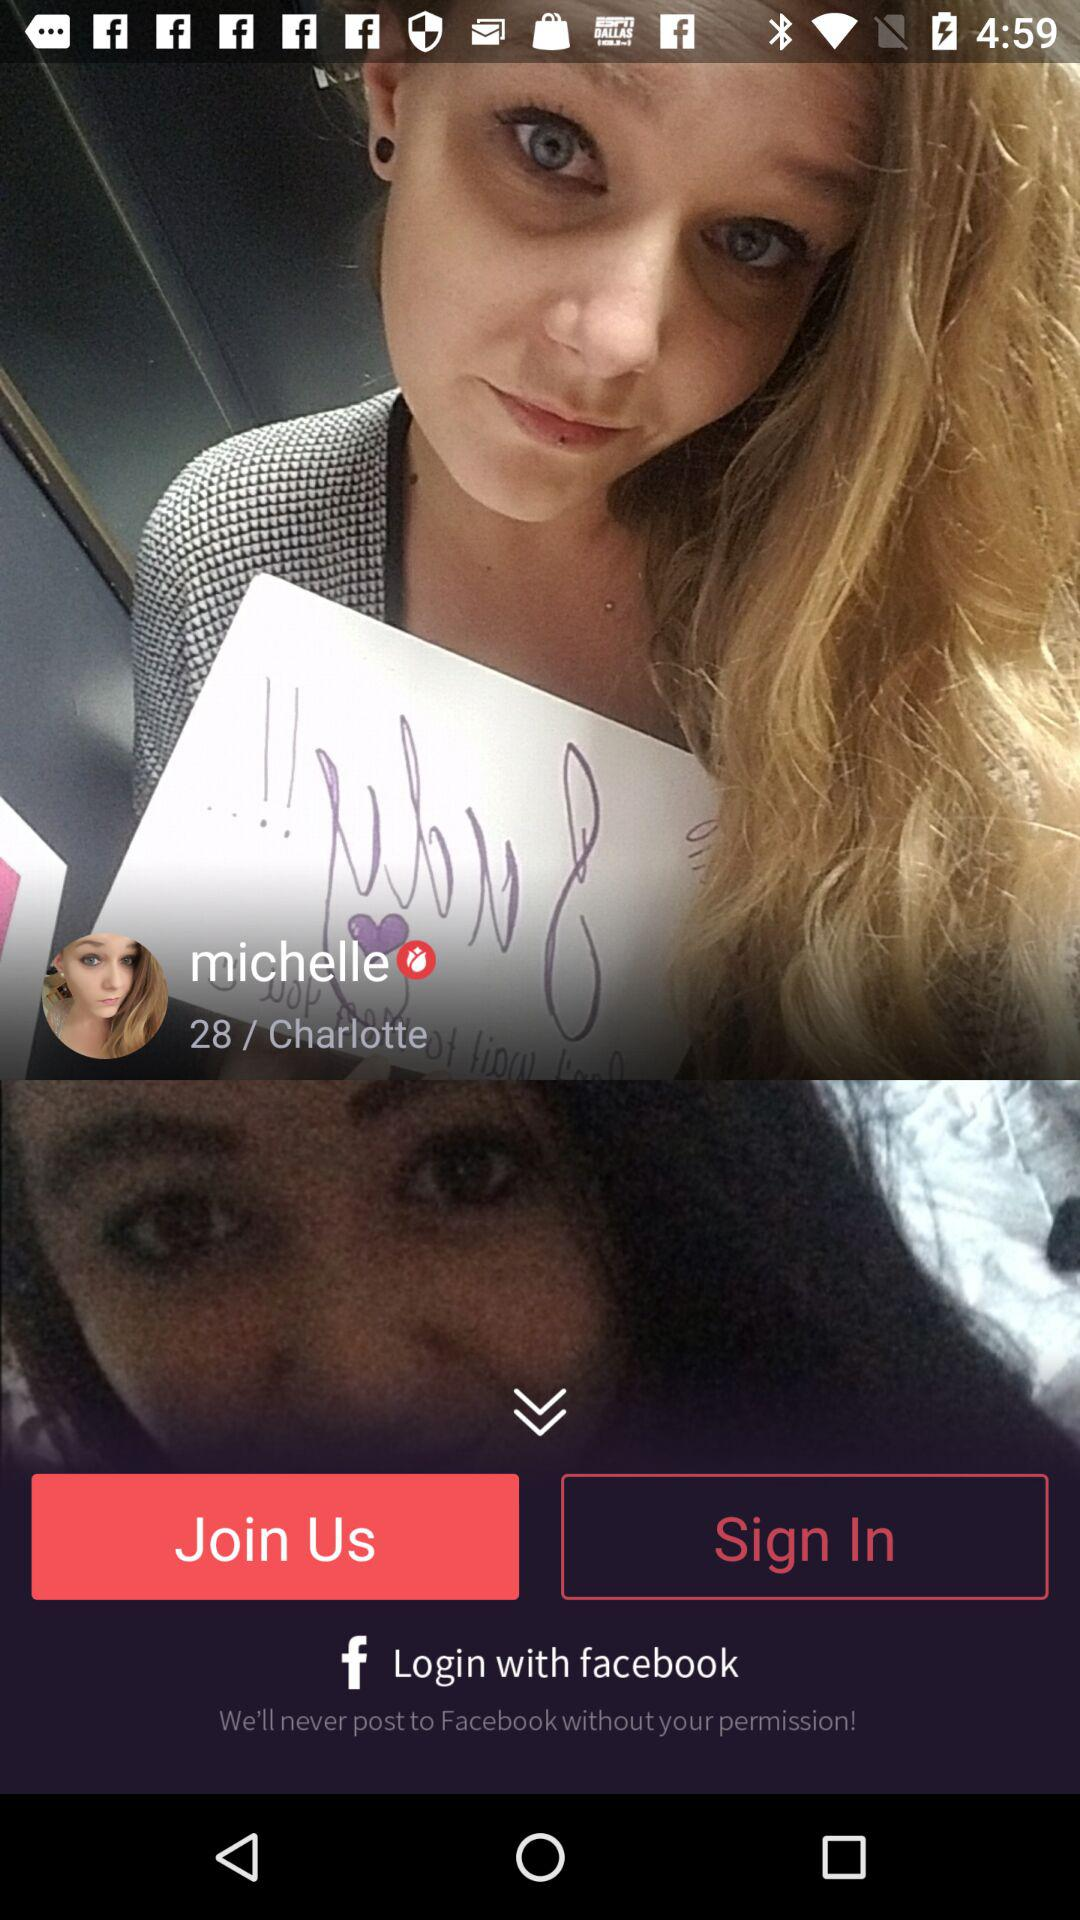What's the age of Michelle? Michelle age is 28. 